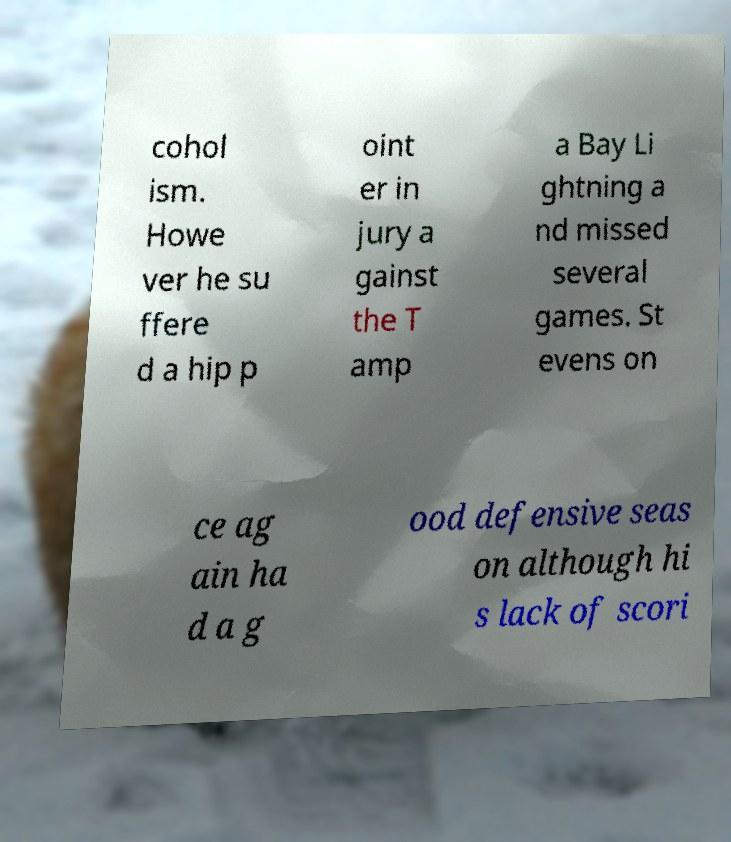What messages or text are displayed in this image? I need them in a readable, typed format. cohol ism. Howe ver he su ffere d a hip p oint er in jury a gainst the T amp a Bay Li ghtning a nd missed several games. St evens on ce ag ain ha d a g ood defensive seas on although hi s lack of scori 